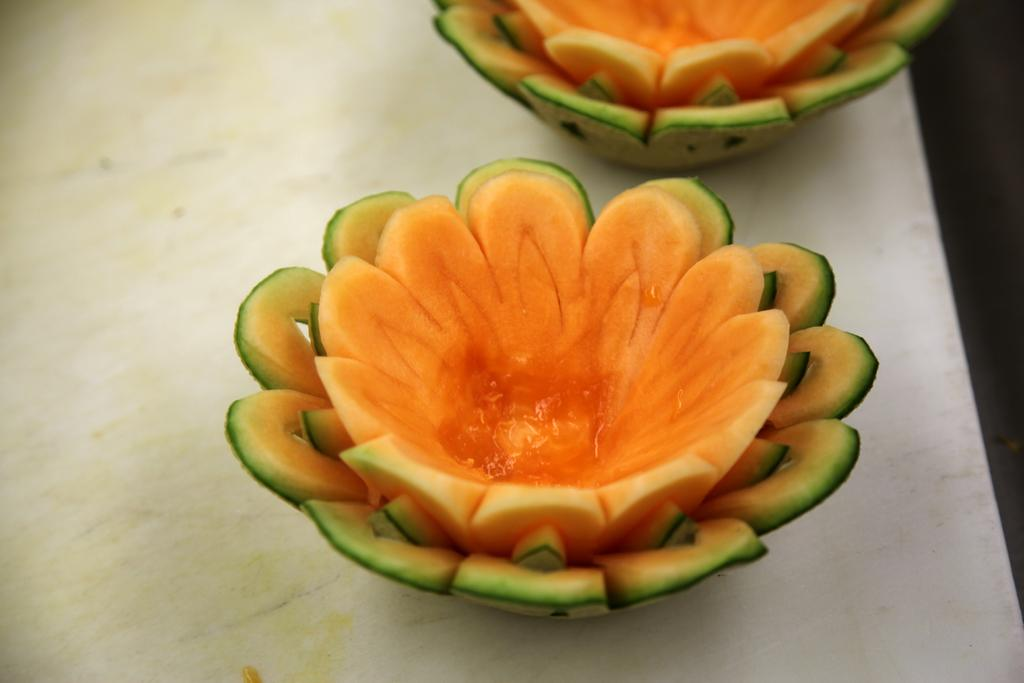What type of food can be seen in the image? There are fruits in the image. How are the fruits arranged or shaped? The fruits are cut in the shape of flowers. What color are the fruits? The fruits are orange in color. On what surface are the fruits placed? The fruits are placed on a white table. Is there an earthquake happening in the image? No, there is no indication of an earthquake in the image. Is anyone wearing a veil in the image? There are no people or veils present in the image. 